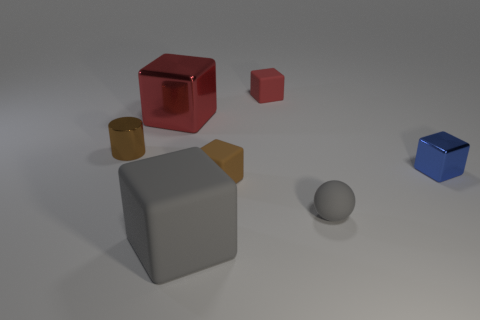There is a small shiny thing on the left side of the sphere; what is its shape?
Make the answer very short. Cylinder. Are there any red things on the left side of the rubber block behind the large red cube?
Make the answer very short. Yes. Is there a red metallic thing of the same size as the blue metal object?
Give a very brief answer. No. Does the tiny rubber block in front of the blue metal cube have the same color as the cylinder?
Offer a very short reply. Yes. How big is the red matte cube?
Offer a terse response. Small. How big is the brown object that is in front of the small brown thing to the left of the big gray object?
Keep it short and to the point. Small. How many tiny things have the same color as the big matte cube?
Offer a terse response. 1. How many green cubes are there?
Keep it short and to the point. 0. How many small balls have the same material as the large gray thing?
Your answer should be compact. 1. There is a brown object that is the same shape as the large red shiny thing; what is its size?
Keep it short and to the point. Small. 